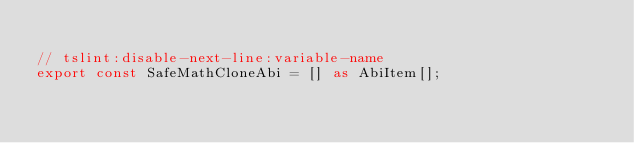Convert code to text. <code><loc_0><loc_0><loc_500><loc_500><_TypeScript_>
// tslint:disable-next-line:variable-name
export const SafeMathCloneAbi = [] as AbiItem[];
</code> 